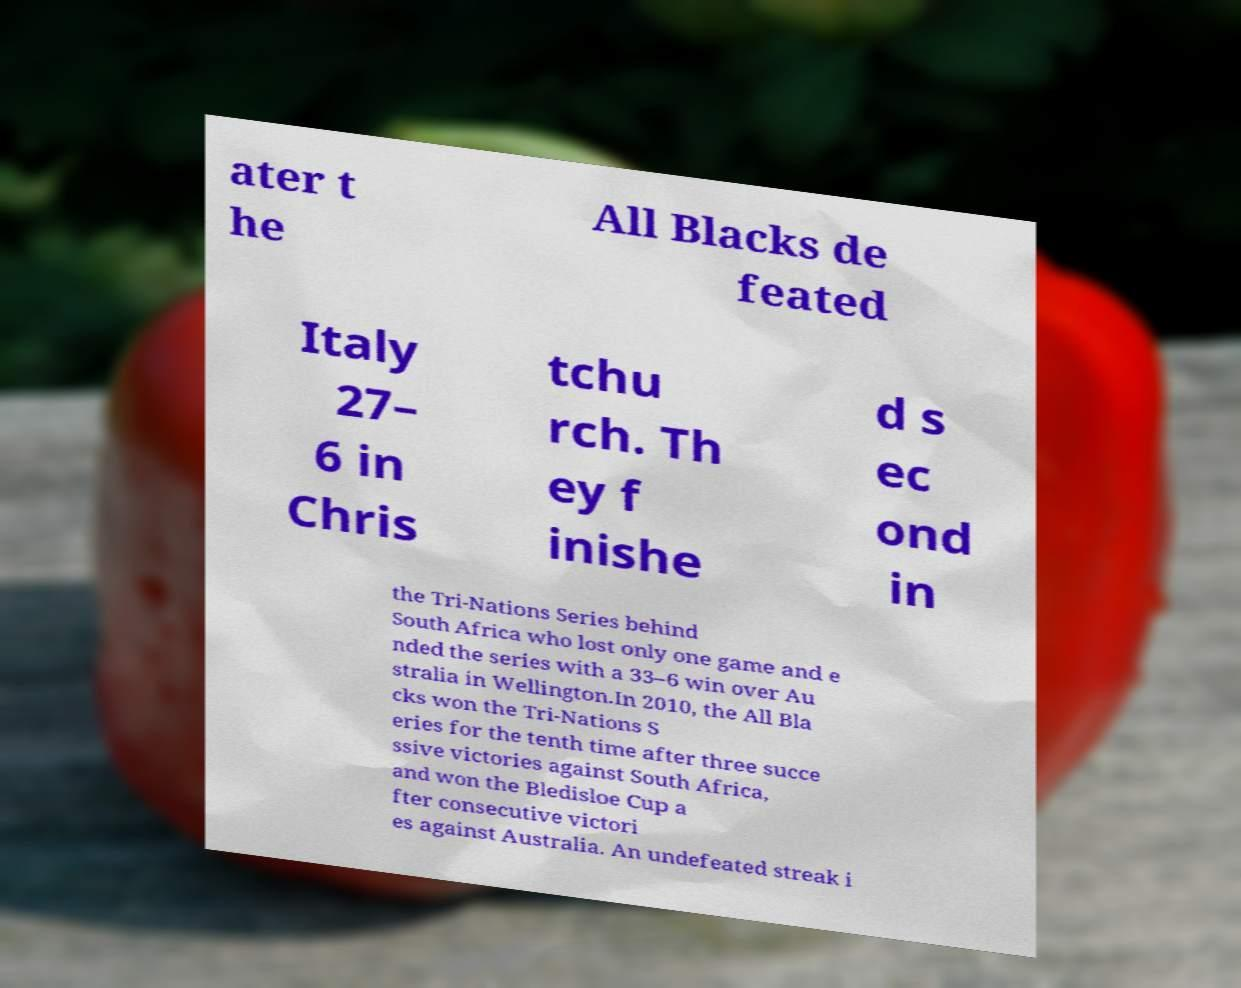For documentation purposes, I need the text within this image transcribed. Could you provide that? ater t he All Blacks de feated Italy 27– 6 in Chris tchu rch. Th ey f inishe d s ec ond in the Tri-Nations Series behind South Africa who lost only one game and e nded the series with a 33–6 win over Au stralia in Wellington.In 2010, the All Bla cks won the Tri-Nations S eries for the tenth time after three succe ssive victories against South Africa, and won the Bledisloe Cup a fter consecutive victori es against Australia. An undefeated streak i 